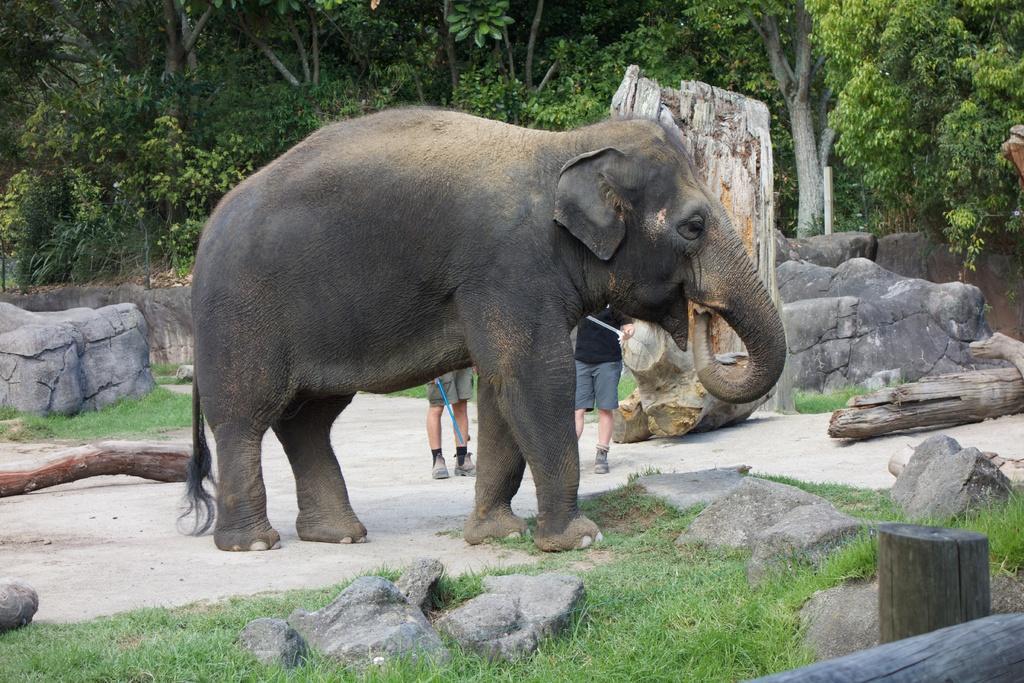In one or two sentences, can you explain what this image depicts? There is an elephant standing in between the rocks and logs,behind the elephant there are two men and around the rocks there are many trees and grass. 